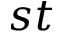<formula> <loc_0><loc_0><loc_500><loc_500>s t</formula> 